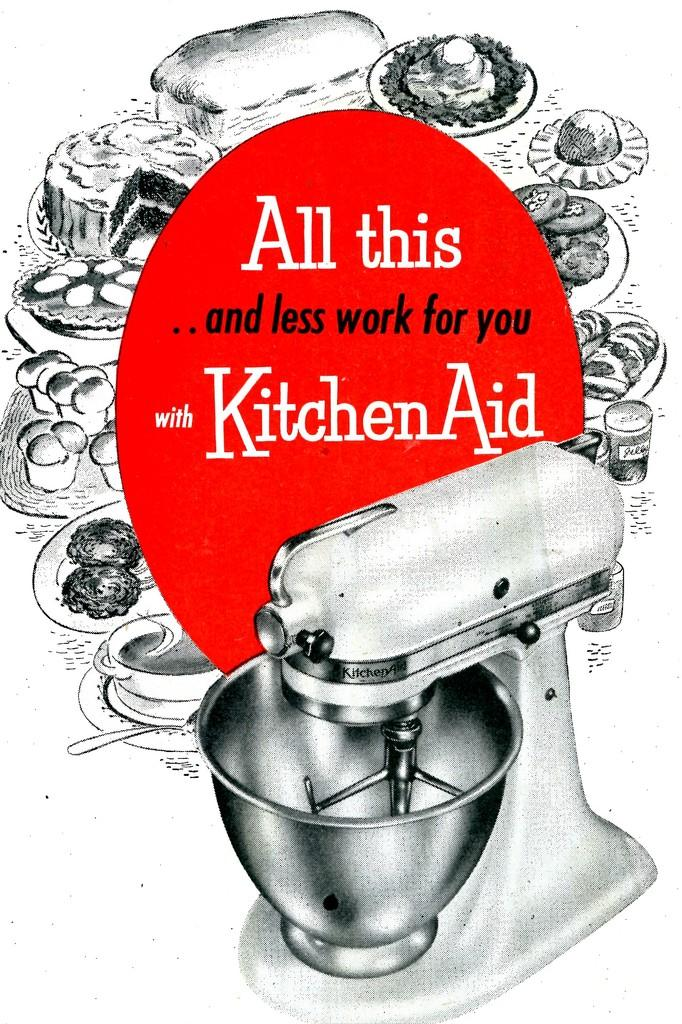<image>
Relay a brief, clear account of the picture shown. A mixer with a silver bowl is advertised by Kitchen Aid. 